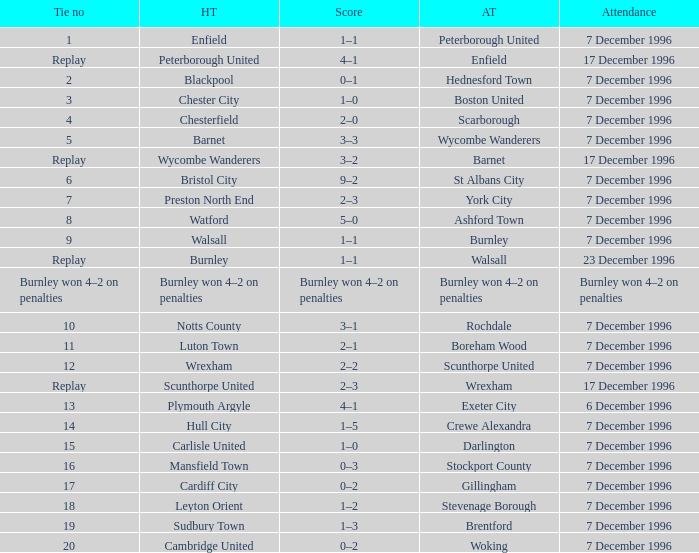Can you give me this table as a dict? {'header': ['Tie no', 'HT', 'Score', 'AT', 'Attendance'], 'rows': [['1', 'Enfield', '1–1', 'Peterborough United', '7 December 1996'], ['Replay', 'Peterborough United', '4–1', 'Enfield', '17 December 1996'], ['2', 'Blackpool', '0–1', 'Hednesford Town', '7 December 1996'], ['3', 'Chester City', '1–0', 'Boston United', '7 December 1996'], ['4', 'Chesterfield', '2–0', 'Scarborough', '7 December 1996'], ['5', 'Barnet', '3–3', 'Wycombe Wanderers', '7 December 1996'], ['Replay', 'Wycombe Wanderers', '3–2', 'Barnet', '17 December 1996'], ['6', 'Bristol City', '9–2', 'St Albans City', '7 December 1996'], ['7', 'Preston North End', '2–3', 'York City', '7 December 1996'], ['8', 'Watford', '5–0', 'Ashford Town', '7 December 1996'], ['9', 'Walsall', '1–1', 'Burnley', '7 December 1996'], ['Replay', 'Burnley', '1–1', 'Walsall', '23 December 1996'], ['Burnley won 4–2 on penalties', 'Burnley won 4–2 on penalties', 'Burnley won 4–2 on penalties', 'Burnley won 4–2 on penalties', 'Burnley won 4–2 on penalties'], ['10', 'Notts County', '3–1', 'Rochdale', '7 December 1996'], ['11', 'Luton Town', '2–1', 'Boreham Wood', '7 December 1996'], ['12', 'Wrexham', '2–2', 'Scunthorpe United', '7 December 1996'], ['Replay', 'Scunthorpe United', '2–3', 'Wrexham', '17 December 1996'], ['13', 'Plymouth Argyle', '4–1', 'Exeter City', '6 December 1996'], ['14', 'Hull City', '1–5', 'Crewe Alexandra', '7 December 1996'], ['15', 'Carlisle United', '1–0', 'Darlington', '7 December 1996'], ['16', 'Mansfield Town', '0–3', 'Stockport County', '7 December 1996'], ['17', 'Cardiff City', '0–2', 'Gillingham', '7 December 1996'], ['18', 'Leyton Orient', '1–2', 'Stevenage Borough', '7 December 1996'], ['19', 'Sudbury Town', '1–3', 'Brentford', '7 December 1996'], ['20', 'Cambridge United', '0–2', 'Woking', '7 December 1996']]} What was the score of tie number 15? 1–0. 